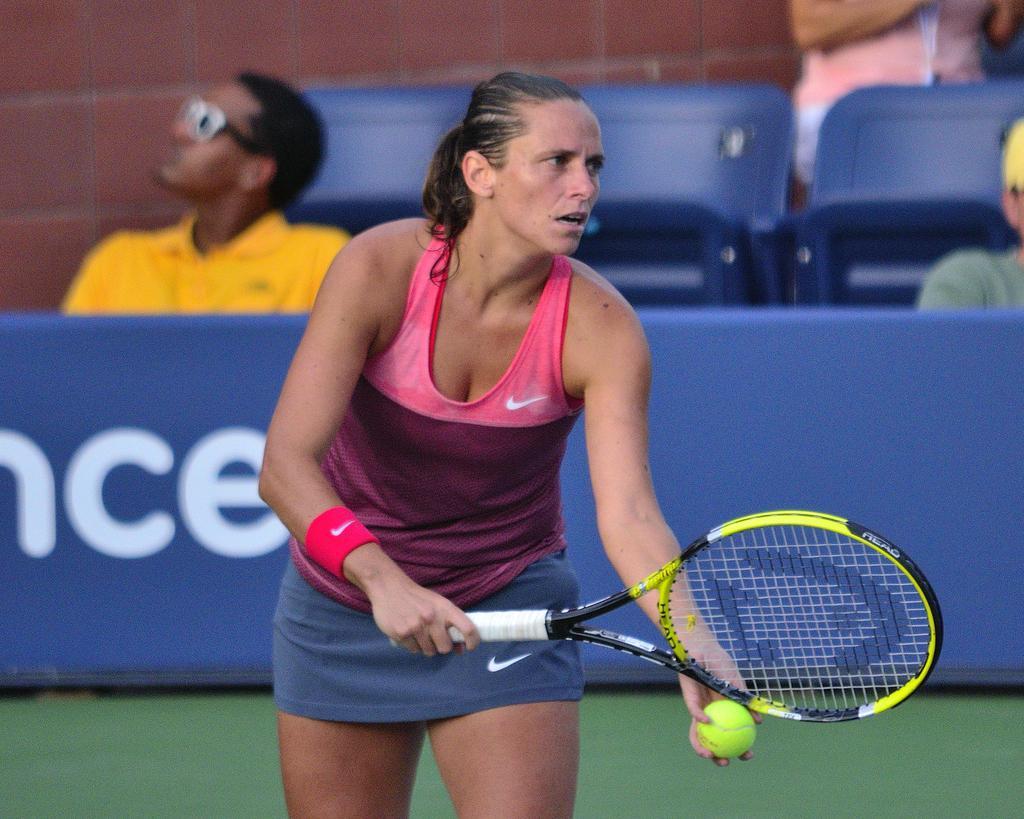Can you describe this image briefly? In this image i can see a woman who is holding a tennis bat and a ball in her hands. The woman is wearing a red color dress and behind the women a man is wearing a yellow color t-shirt and a glasses is sitting on the chair. And in the right side of the image there are few people who are also sitting on the chair. 